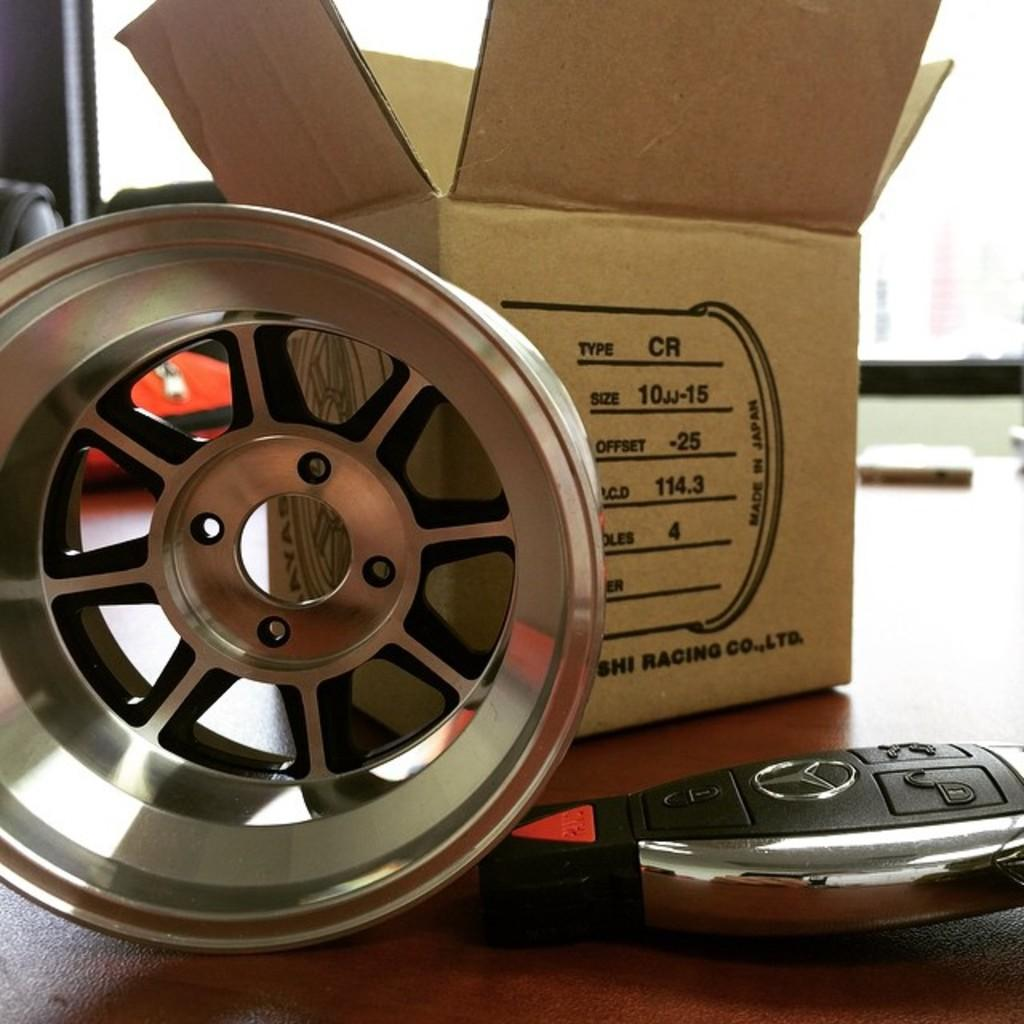What is the main object in the image? There is a box in the image. What else can be seen in the image besides the box? There is a rim and a car smart key in the image. Where are these objects located? The objects are on a platform. How would you describe the background of the image? The background of the image is blurred. What type of bun is being used to hold the car smart key in the image? There is no bun present in the image; the car smart key is not being held by any type of bun. 